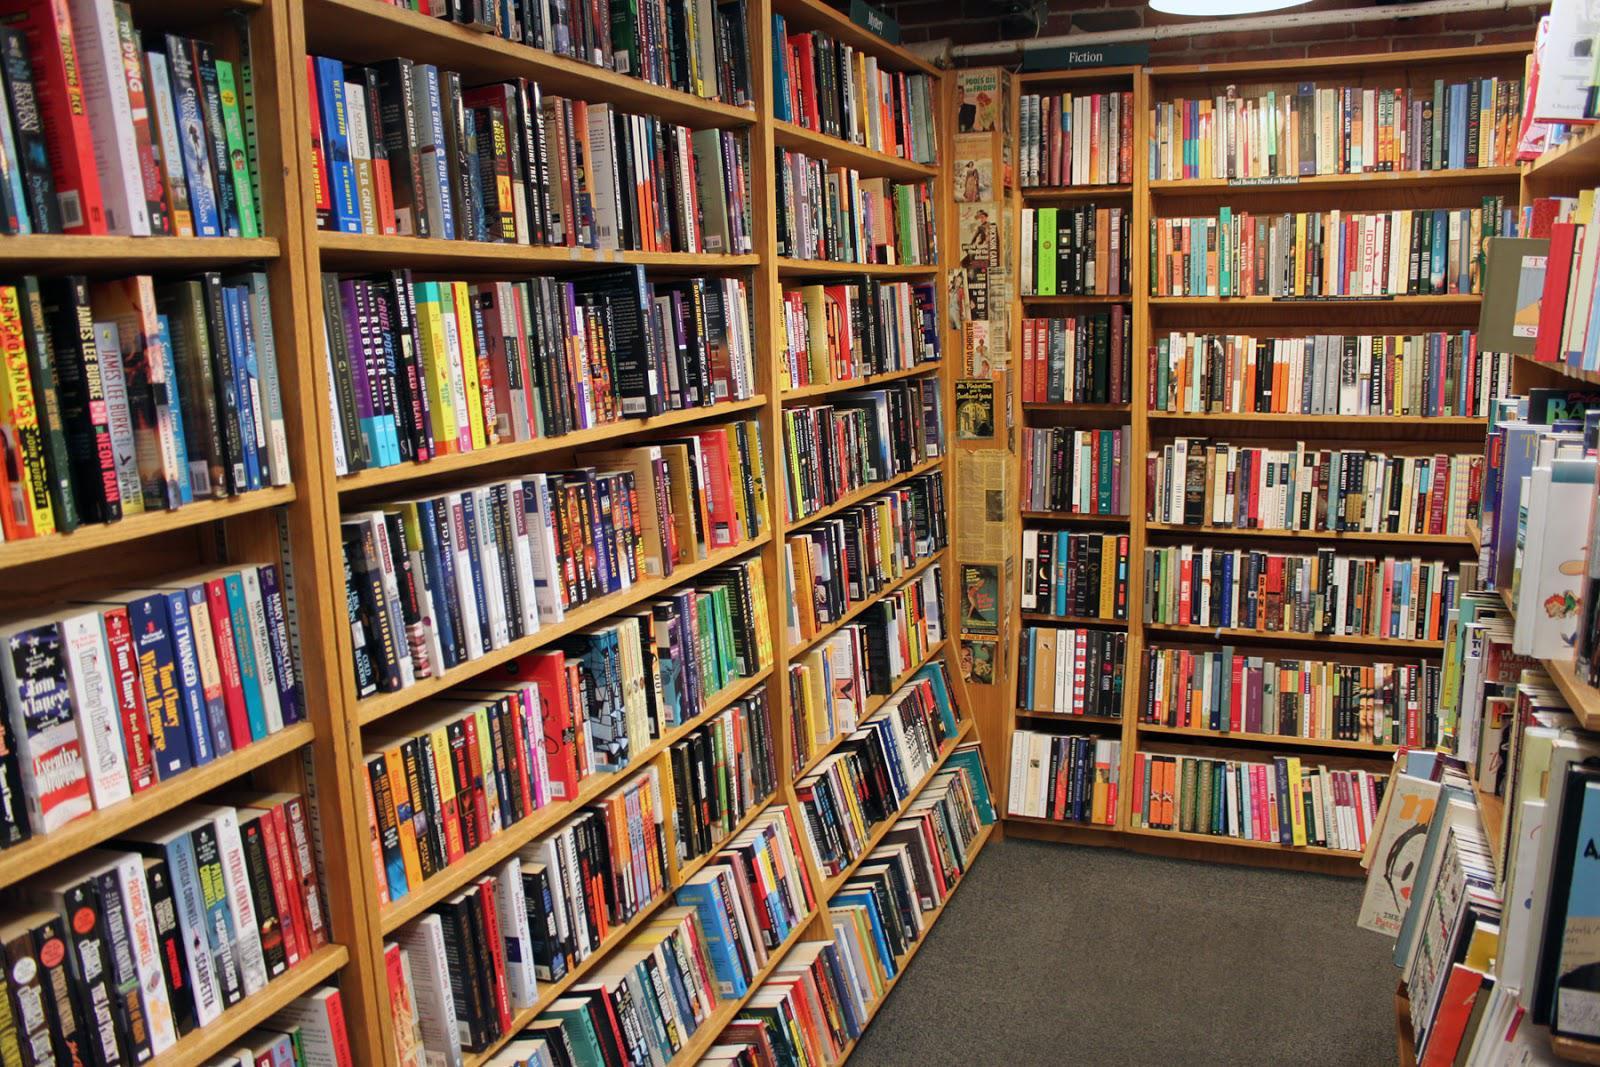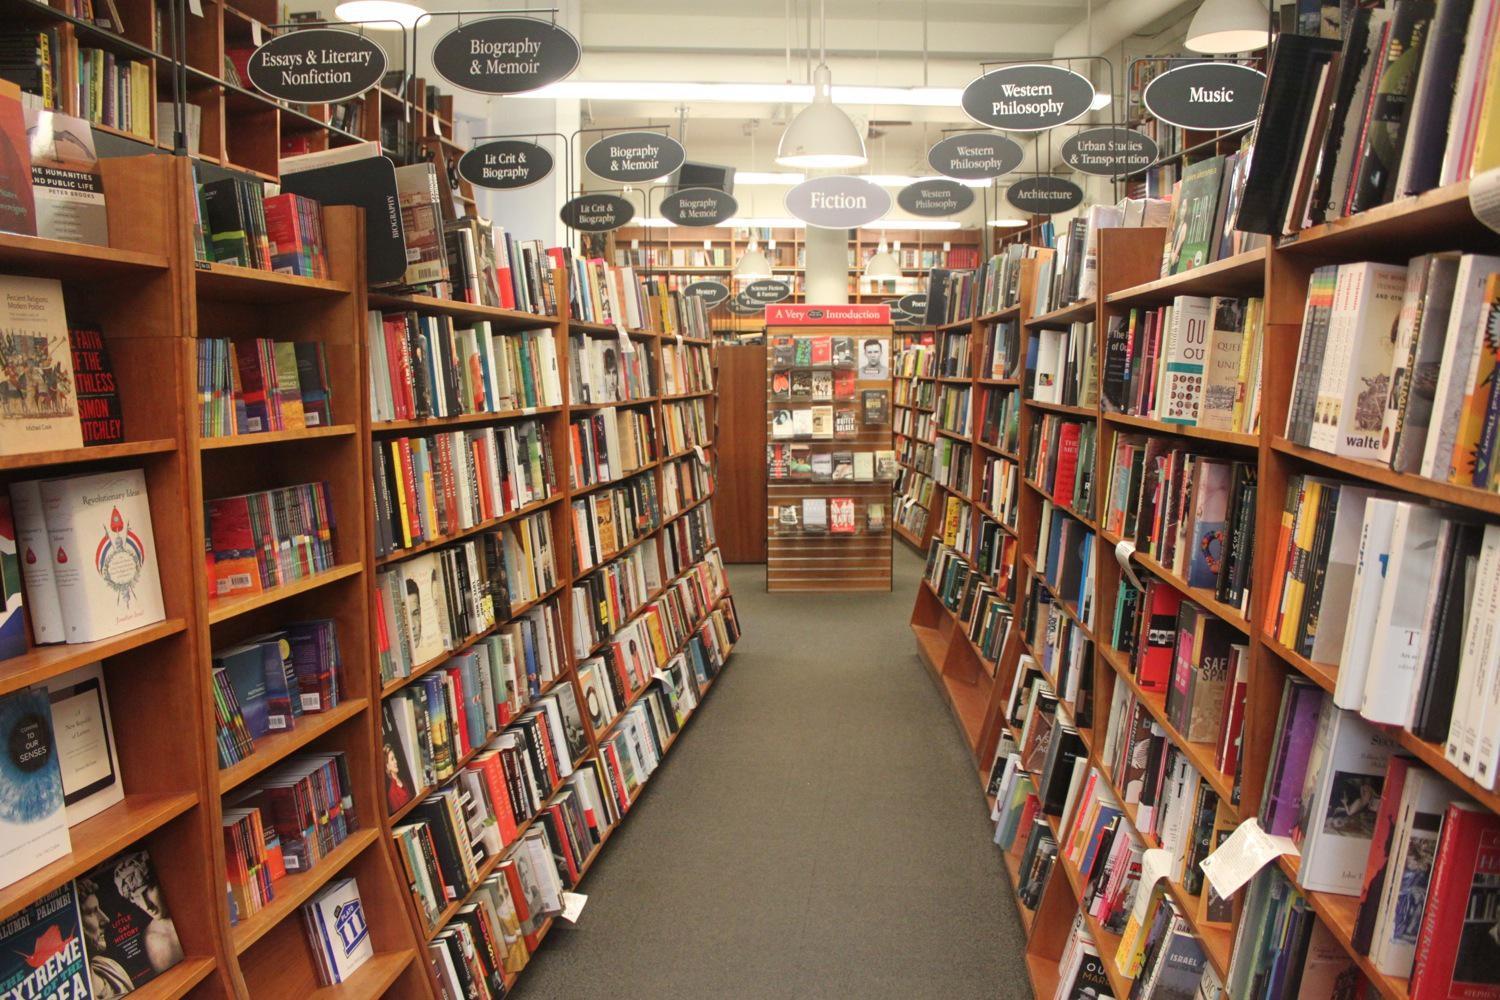The first image is the image on the left, the second image is the image on the right. Given the left and right images, does the statement "In at least one image there is a woman with an open book in her hands standing in front of a bookshelf on the left." hold true? Answer yes or no. No. The first image is the image on the left, the second image is the image on the right. For the images displayed, is the sentence "The right image features one woman with a bag slung on her back, standing with her back to the camera and facing leftward toward a solid wall of books on shelves." factually correct? Answer yes or no. No. 